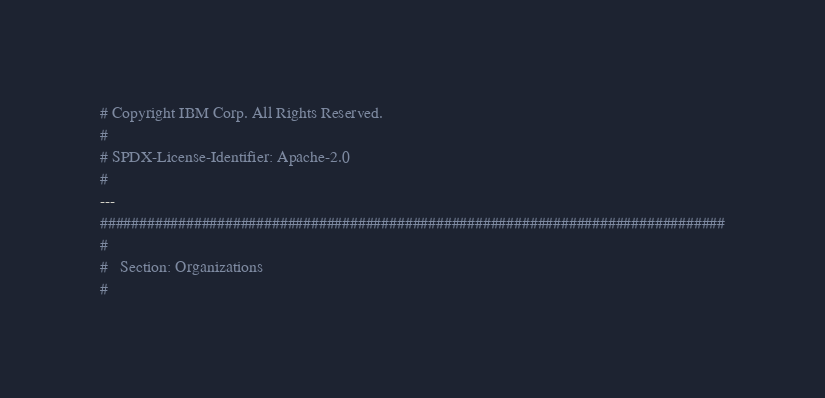Convert code to text. <code><loc_0><loc_0><loc_500><loc_500><_YAML_># Copyright IBM Corp. All Rights Reserved.
#
# SPDX-License-Identifier: Apache-2.0
#
---
################################################################################
#
#   Section: Organizations
#</code> 